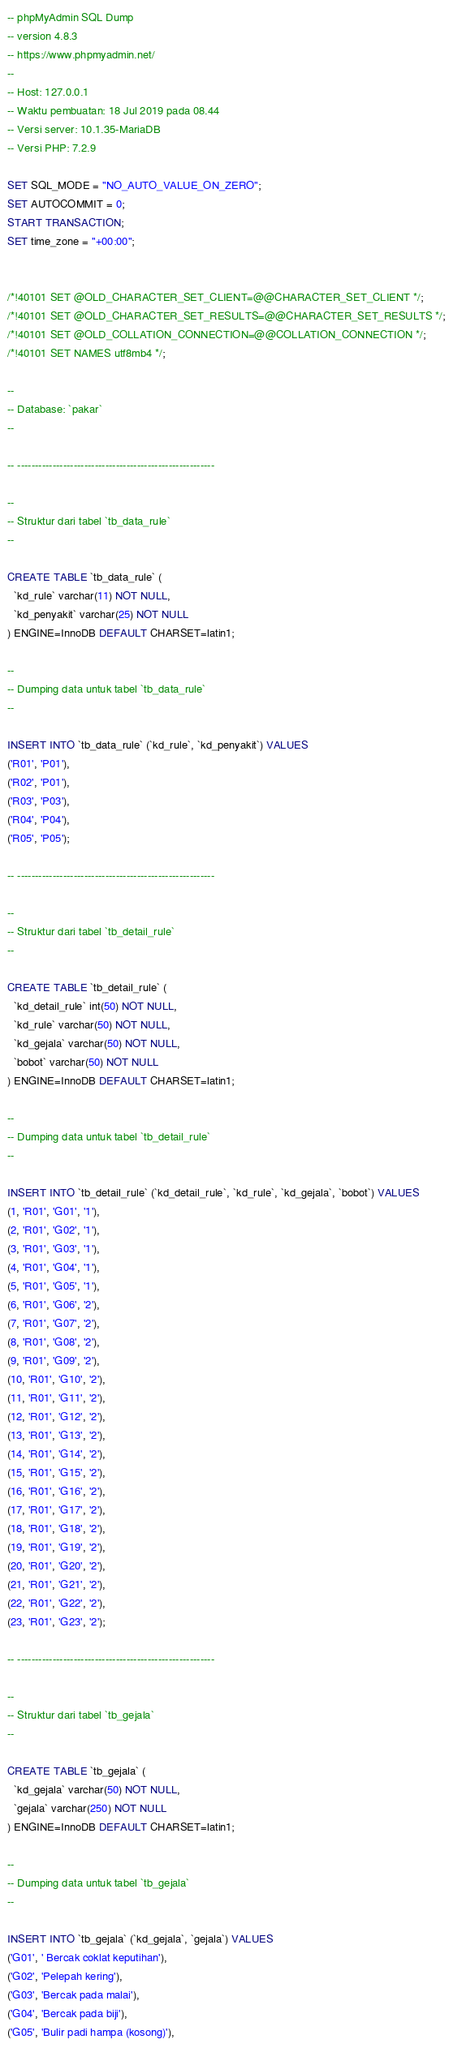<code> <loc_0><loc_0><loc_500><loc_500><_SQL_>-- phpMyAdmin SQL Dump
-- version 4.8.3
-- https://www.phpmyadmin.net/
--
-- Host: 127.0.0.1
-- Waktu pembuatan: 18 Jul 2019 pada 08.44
-- Versi server: 10.1.35-MariaDB
-- Versi PHP: 7.2.9

SET SQL_MODE = "NO_AUTO_VALUE_ON_ZERO";
SET AUTOCOMMIT = 0;
START TRANSACTION;
SET time_zone = "+00:00";


/*!40101 SET @OLD_CHARACTER_SET_CLIENT=@@CHARACTER_SET_CLIENT */;
/*!40101 SET @OLD_CHARACTER_SET_RESULTS=@@CHARACTER_SET_RESULTS */;
/*!40101 SET @OLD_COLLATION_CONNECTION=@@COLLATION_CONNECTION */;
/*!40101 SET NAMES utf8mb4 */;

--
-- Database: `pakar`
--

-- --------------------------------------------------------

--
-- Struktur dari tabel `tb_data_rule`
--

CREATE TABLE `tb_data_rule` (
  `kd_rule` varchar(11) NOT NULL,
  `kd_penyakit` varchar(25) NOT NULL
) ENGINE=InnoDB DEFAULT CHARSET=latin1;

--
-- Dumping data untuk tabel `tb_data_rule`
--

INSERT INTO `tb_data_rule` (`kd_rule`, `kd_penyakit`) VALUES
('R01', 'P01'),
('R02', 'P01'),
('R03', 'P03'),
('R04', 'P04'),
('R05', 'P05');

-- --------------------------------------------------------

--
-- Struktur dari tabel `tb_detail_rule`
--

CREATE TABLE `tb_detail_rule` (
  `kd_detail_rule` int(50) NOT NULL,
  `kd_rule` varchar(50) NOT NULL,
  `kd_gejala` varchar(50) NOT NULL,
  `bobot` varchar(50) NOT NULL
) ENGINE=InnoDB DEFAULT CHARSET=latin1;

--
-- Dumping data untuk tabel `tb_detail_rule`
--

INSERT INTO `tb_detail_rule` (`kd_detail_rule`, `kd_rule`, `kd_gejala`, `bobot`) VALUES
(1, 'R01', 'G01', '1'),
(2, 'R01', 'G02', '1'),
(3, 'R01', 'G03', '1'),
(4, 'R01', 'G04', '1'),
(5, 'R01', 'G05', '1'),
(6, 'R01', 'G06', '2'),
(7, 'R01', 'G07', '2'),
(8, 'R01', 'G08', '2'),
(9, 'R01', 'G09', '2'),
(10, 'R01', 'G10', '2'),
(11, 'R01', 'G11', '2'),
(12, 'R01', 'G12', '2'),
(13, 'R01', 'G13', '2'),
(14, 'R01', 'G14', '2'),
(15, 'R01', 'G15', '2'),
(16, 'R01', 'G16', '2'),
(17, 'R01', 'G17', '2'),
(18, 'R01', 'G18', '2'),
(19, 'R01', 'G19', '2'),
(20, 'R01', 'G20', '2'),
(21, 'R01', 'G21', '2'),
(22, 'R01', 'G22', '2'),
(23, 'R01', 'G23', '2');

-- --------------------------------------------------------

--
-- Struktur dari tabel `tb_gejala`
--

CREATE TABLE `tb_gejala` (
  `kd_gejala` varchar(50) NOT NULL,
  `gejala` varchar(250) NOT NULL
) ENGINE=InnoDB DEFAULT CHARSET=latin1;

--
-- Dumping data untuk tabel `tb_gejala`
--

INSERT INTO `tb_gejala` (`kd_gejala`, `gejala`) VALUES
('G01', ' Bercak coklat keputihan'),
('G02', 'Pelepah kering'),
('G03', 'Bercak pada malai'),
('G04', 'Bercak pada biji'),
('G05', 'Bulir padi hampa (kosong)'),</code> 